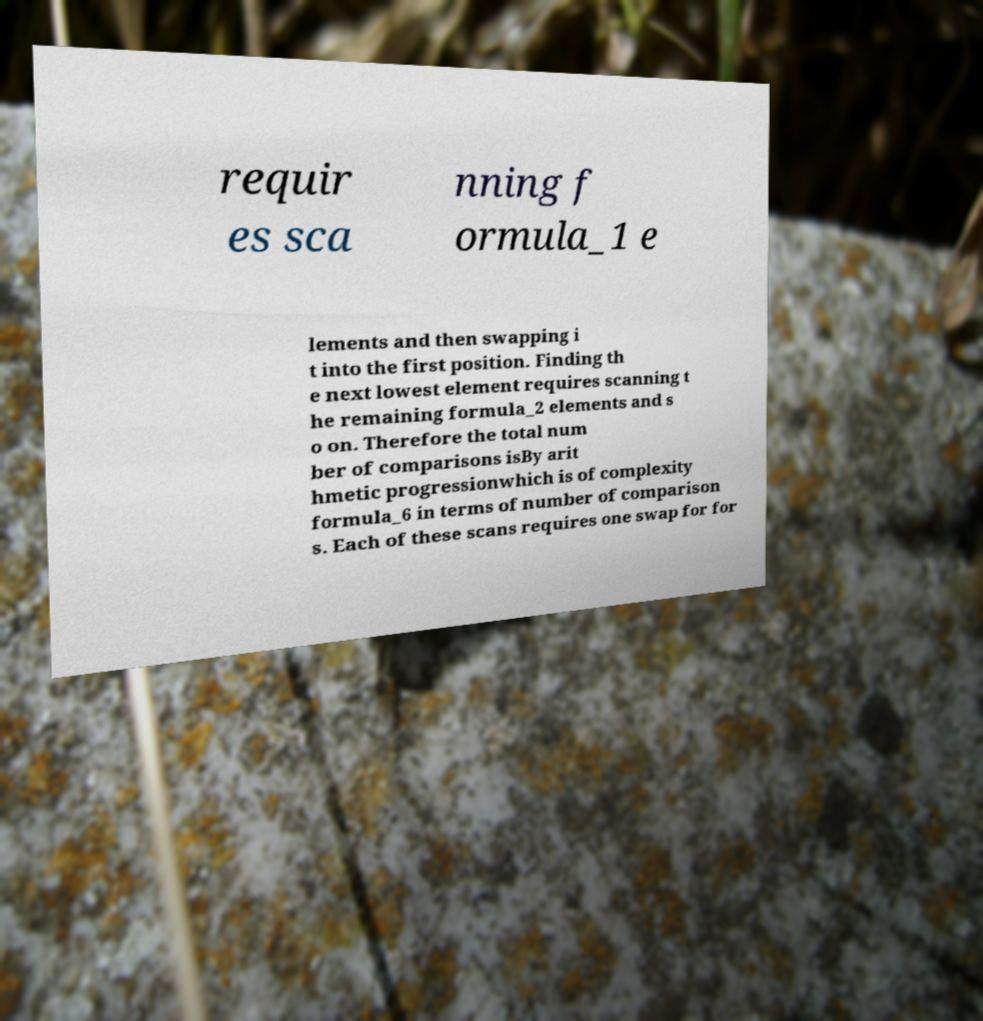For documentation purposes, I need the text within this image transcribed. Could you provide that? requir es sca nning f ormula_1 e lements and then swapping i t into the first position. Finding th e next lowest element requires scanning t he remaining formula_2 elements and s o on. Therefore the total num ber of comparisons isBy arit hmetic progressionwhich is of complexity formula_6 in terms of number of comparison s. Each of these scans requires one swap for for 